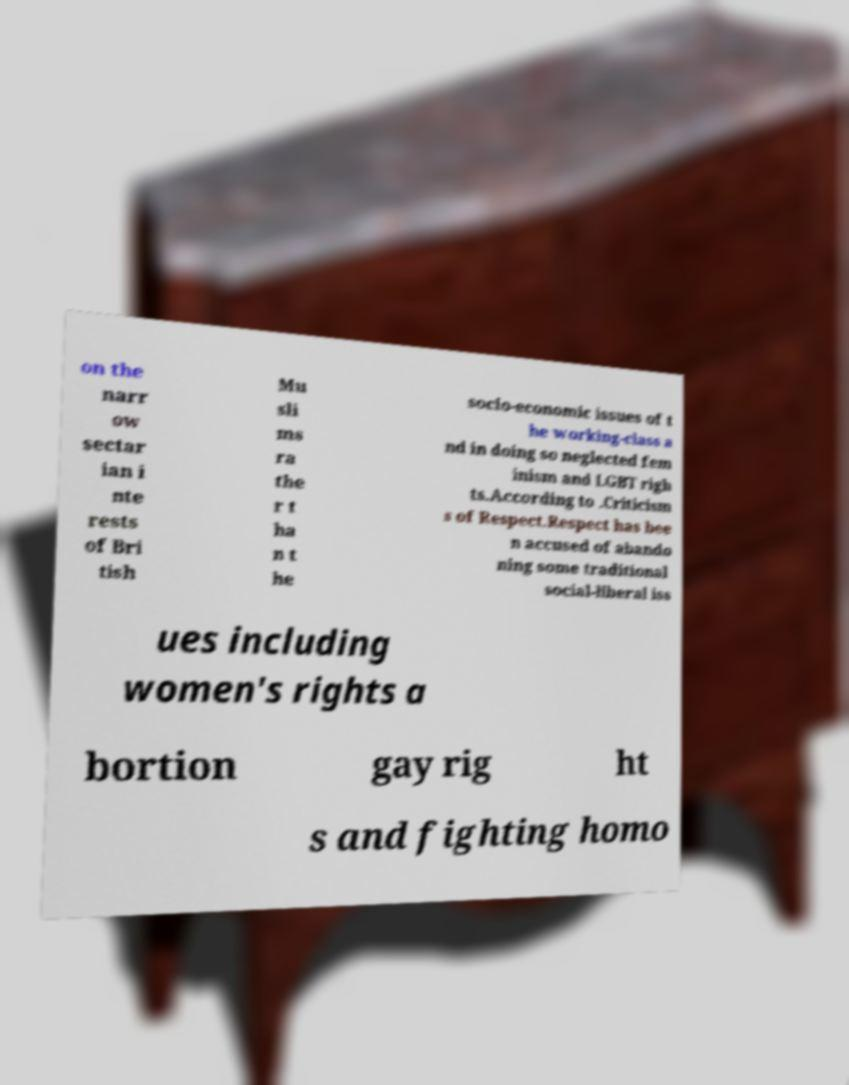I need the written content from this picture converted into text. Can you do that? on the narr ow sectar ian i nte rests of Bri tish Mu sli ms ra the r t ha n t he socio-economic issues of t he working-class a nd in doing so neglected fem inism and LGBT righ ts.According to .Criticism s of Respect.Respect has bee n accused of abando ning some traditional social-liberal iss ues including women's rights a bortion gay rig ht s and fighting homo 